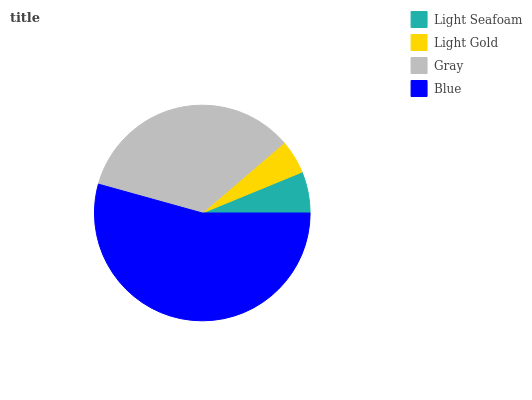Is Light Gold the minimum?
Answer yes or no. Yes. Is Blue the maximum?
Answer yes or no. Yes. Is Gray the minimum?
Answer yes or no. No. Is Gray the maximum?
Answer yes or no. No. Is Gray greater than Light Gold?
Answer yes or no. Yes. Is Light Gold less than Gray?
Answer yes or no. Yes. Is Light Gold greater than Gray?
Answer yes or no. No. Is Gray less than Light Gold?
Answer yes or no. No. Is Gray the high median?
Answer yes or no. Yes. Is Light Seafoam the low median?
Answer yes or no. Yes. Is Blue the high median?
Answer yes or no. No. Is Gray the low median?
Answer yes or no. No. 